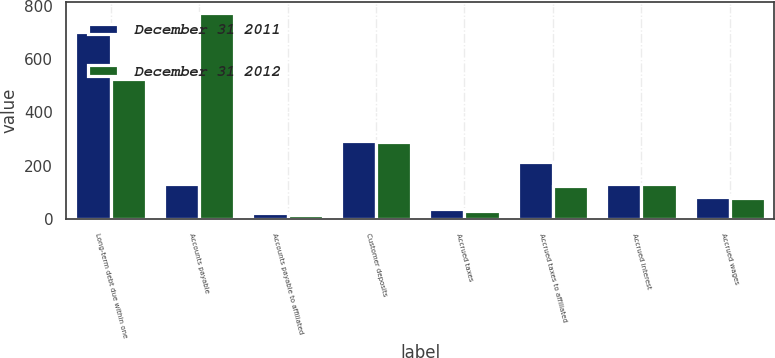<chart> <loc_0><loc_0><loc_500><loc_500><stacked_bar_chart><ecel><fcel>Long-term debt due within one<fcel>Accounts payable<fcel>Accounts payable to affiliated<fcel>Customer deposits<fcel>Accrued taxes<fcel>Accrued taxes to affiliated<fcel>Accrued interest<fcel>Accrued wages<nl><fcel>December 31 2011<fcel>700<fcel>133<fcel>22<fcel>292<fcel>37<fcel>215<fcel>133<fcel>84<nl><fcel>December 31 2012<fcel>525<fcel>774<fcel>16<fcel>290<fcel>32<fcel>126<fcel>133<fcel>81<nl></chart> 